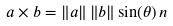<formula> <loc_0><loc_0><loc_500><loc_500>a \times b = \left \| a \right \| \left \| b \right \| \sin ( \theta ) \, n</formula> 